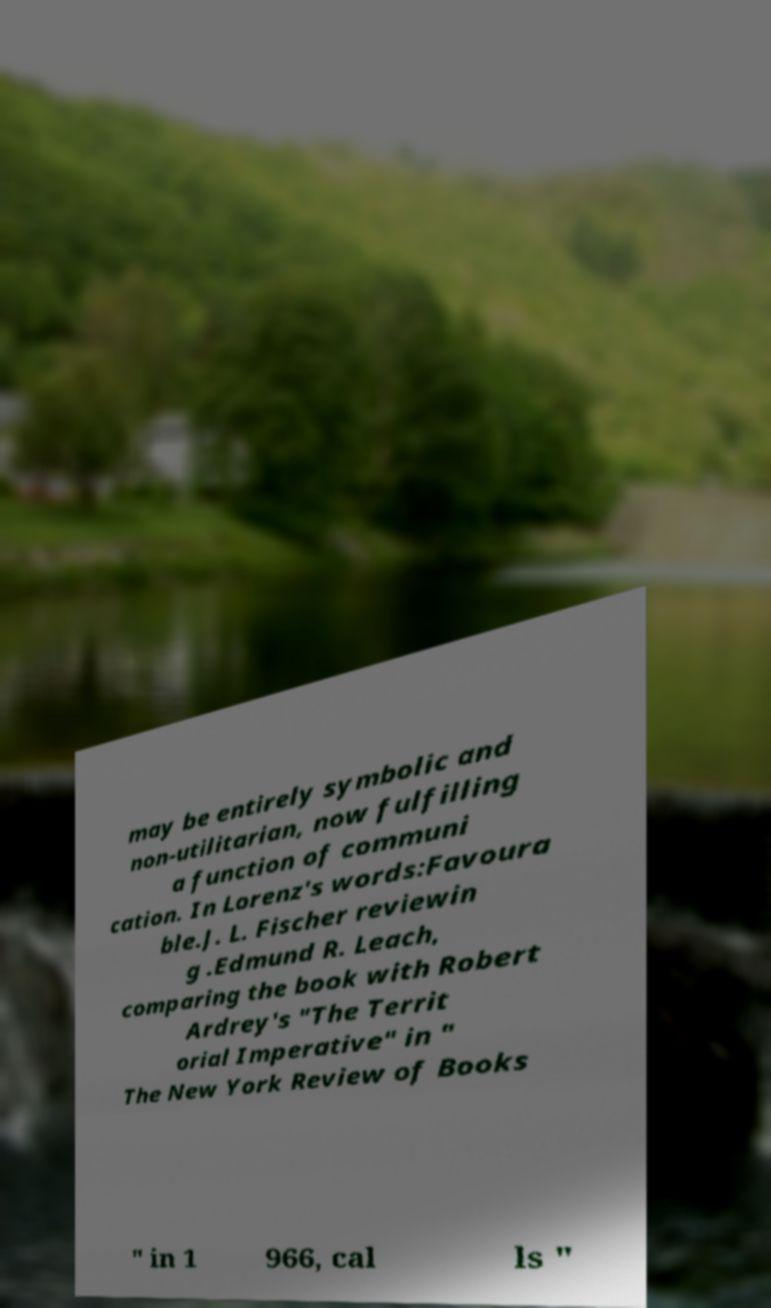Could you assist in decoding the text presented in this image and type it out clearly? may be entirely symbolic and non-utilitarian, now fulfilling a function of communi cation. In Lorenz's words:Favoura ble.J. L. Fischer reviewin g .Edmund R. Leach, comparing the book with Robert Ardrey's "The Territ orial Imperative" in " The New York Review of Books " in 1 966, cal ls " 